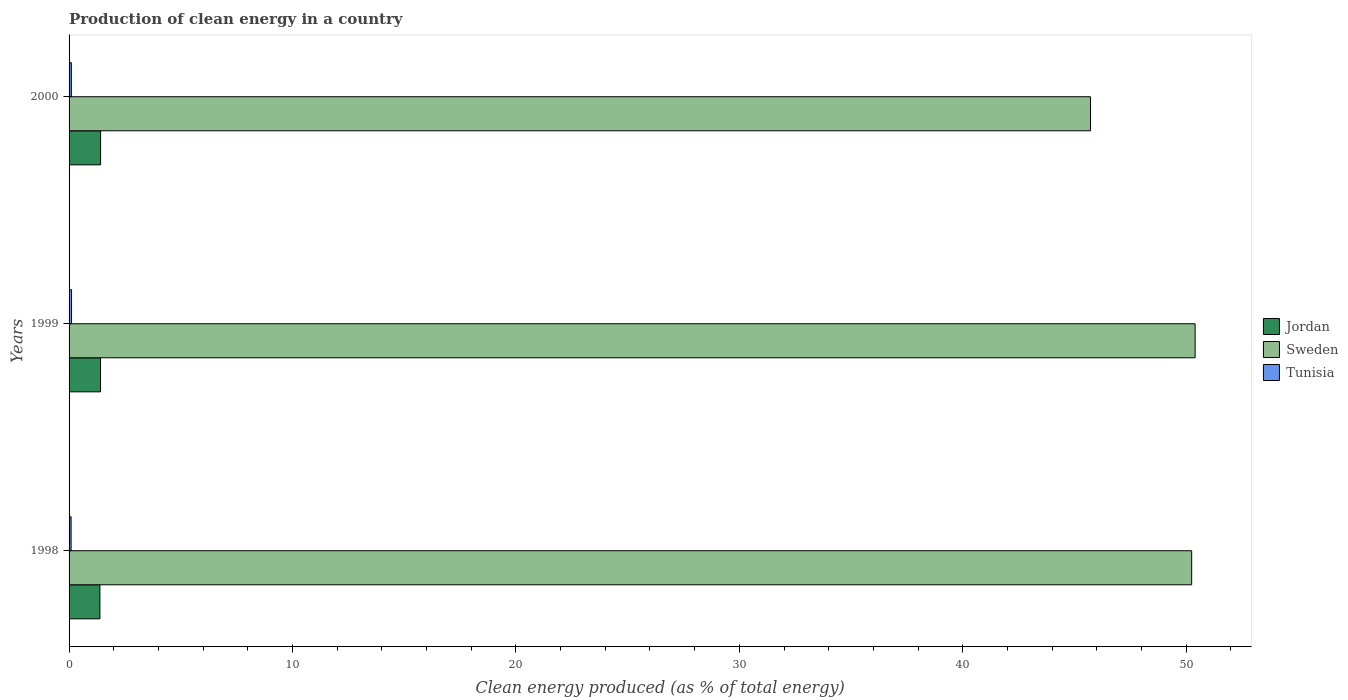How many groups of bars are there?
Your response must be concise. 3. Are the number of bars per tick equal to the number of legend labels?
Your answer should be very brief. Yes. Are the number of bars on each tick of the Y-axis equal?
Provide a short and direct response. Yes. How many bars are there on the 3rd tick from the bottom?
Offer a very short reply. 3. In how many cases, is the number of bars for a given year not equal to the number of legend labels?
Your answer should be very brief. 0. What is the percentage of clean energy produced in Sweden in 1998?
Give a very brief answer. 50.24. Across all years, what is the maximum percentage of clean energy produced in Tunisia?
Your response must be concise. 0.11. Across all years, what is the minimum percentage of clean energy produced in Sweden?
Your response must be concise. 45.71. In which year was the percentage of clean energy produced in Tunisia maximum?
Make the answer very short. 1999. What is the total percentage of clean energy produced in Jordan in the graph?
Your response must be concise. 4.2. What is the difference between the percentage of clean energy produced in Jordan in 1998 and that in 1999?
Make the answer very short. -0.03. What is the difference between the percentage of clean energy produced in Jordan in 2000 and the percentage of clean energy produced in Sweden in 1998?
Provide a succinct answer. -48.83. What is the average percentage of clean energy produced in Jordan per year?
Offer a very short reply. 1.4. In the year 1999, what is the difference between the percentage of clean energy produced in Jordan and percentage of clean energy produced in Tunisia?
Offer a terse response. 1.3. What is the ratio of the percentage of clean energy produced in Jordan in 1998 to that in 2000?
Your response must be concise. 0.98. What is the difference between the highest and the second highest percentage of clean energy produced in Sweden?
Offer a terse response. 0.15. What is the difference between the highest and the lowest percentage of clean energy produced in Tunisia?
Give a very brief answer. 0.02. What does the 2nd bar from the top in 1998 represents?
Give a very brief answer. Sweden. Is it the case that in every year, the sum of the percentage of clean energy produced in Tunisia and percentage of clean energy produced in Sweden is greater than the percentage of clean energy produced in Jordan?
Ensure brevity in your answer.  Yes. Are all the bars in the graph horizontal?
Keep it short and to the point. Yes. Does the graph contain any zero values?
Offer a terse response. No. Where does the legend appear in the graph?
Provide a short and direct response. Center right. How are the legend labels stacked?
Ensure brevity in your answer.  Vertical. What is the title of the graph?
Your response must be concise. Production of clean energy in a country. Does "Comoros" appear as one of the legend labels in the graph?
Offer a very short reply. No. What is the label or title of the X-axis?
Provide a short and direct response. Clean energy produced (as % of total energy). What is the label or title of the Y-axis?
Offer a very short reply. Years. What is the Clean energy produced (as % of total energy) in Jordan in 1998?
Your response must be concise. 1.38. What is the Clean energy produced (as % of total energy) of Sweden in 1998?
Your answer should be very brief. 50.24. What is the Clean energy produced (as % of total energy) of Tunisia in 1998?
Offer a terse response. 0.09. What is the Clean energy produced (as % of total energy) in Jordan in 1999?
Your response must be concise. 1.41. What is the Clean energy produced (as % of total energy) of Sweden in 1999?
Give a very brief answer. 50.4. What is the Clean energy produced (as % of total energy) in Tunisia in 1999?
Ensure brevity in your answer.  0.11. What is the Clean energy produced (as % of total energy) in Jordan in 2000?
Give a very brief answer. 1.41. What is the Clean energy produced (as % of total energy) in Sweden in 2000?
Your answer should be very brief. 45.71. What is the Clean energy produced (as % of total energy) of Tunisia in 2000?
Make the answer very short. 0.1. Across all years, what is the maximum Clean energy produced (as % of total energy) of Jordan?
Give a very brief answer. 1.41. Across all years, what is the maximum Clean energy produced (as % of total energy) in Sweden?
Your answer should be compact. 50.4. Across all years, what is the maximum Clean energy produced (as % of total energy) of Tunisia?
Make the answer very short. 0.11. Across all years, what is the minimum Clean energy produced (as % of total energy) in Jordan?
Your answer should be compact. 1.38. Across all years, what is the minimum Clean energy produced (as % of total energy) in Sweden?
Your answer should be very brief. 45.71. Across all years, what is the minimum Clean energy produced (as % of total energy) in Tunisia?
Provide a succinct answer. 0.09. What is the total Clean energy produced (as % of total energy) of Jordan in the graph?
Keep it short and to the point. 4.2. What is the total Clean energy produced (as % of total energy) in Sweden in the graph?
Provide a short and direct response. 146.36. What is the total Clean energy produced (as % of total energy) of Tunisia in the graph?
Give a very brief answer. 0.3. What is the difference between the Clean energy produced (as % of total energy) of Jordan in 1998 and that in 1999?
Your answer should be very brief. -0.03. What is the difference between the Clean energy produced (as % of total energy) of Sweden in 1998 and that in 1999?
Provide a short and direct response. -0.15. What is the difference between the Clean energy produced (as % of total energy) in Tunisia in 1998 and that in 1999?
Your response must be concise. -0.02. What is the difference between the Clean energy produced (as % of total energy) in Jordan in 1998 and that in 2000?
Offer a very short reply. -0.03. What is the difference between the Clean energy produced (as % of total energy) of Sweden in 1998 and that in 2000?
Provide a short and direct response. 4.53. What is the difference between the Clean energy produced (as % of total energy) in Tunisia in 1998 and that in 2000?
Your answer should be compact. -0.01. What is the difference between the Clean energy produced (as % of total energy) of Jordan in 1999 and that in 2000?
Your response must be concise. -0. What is the difference between the Clean energy produced (as % of total energy) in Sweden in 1999 and that in 2000?
Keep it short and to the point. 4.68. What is the difference between the Clean energy produced (as % of total energy) in Tunisia in 1999 and that in 2000?
Your response must be concise. 0.01. What is the difference between the Clean energy produced (as % of total energy) in Jordan in 1998 and the Clean energy produced (as % of total energy) in Sweden in 1999?
Offer a very short reply. -49.02. What is the difference between the Clean energy produced (as % of total energy) of Jordan in 1998 and the Clean energy produced (as % of total energy) of Tunisia in 1999?
Offer a very short reply. 1.27. What is the difference between the Clean energy produced (as % of total energy) of Sweden in 1998 and the Clean energy produced (as % of total energy) of Tunisia in 1999?
Keep it short and to the point. 50.13. What is the difference between the Clean energy produced (as % of total energy) of Jordan in 1998 and the Clean energy produced (as % of total energy) of Sweden in 2000?
Provide a short and direct response. -44.33. What is the difference between the Clean energy produced (as % of total energy) in Jordan in 1998 and the Clean energy produced (as % of total energy) in Tunisia in 2000?
Your answer should be compact. 1.28. What is the difference between the Clean energy produced (as % of total energy) in Sweden in 1998 and the Clean energy produced (as % of total energy) in Tunisia in 2000?
Provide a short and direct response. 50.14. What is the difference between the Clean energy produced (as % of total energy) of Jordan in 1999 and the Clean energy produced (as % of total energy) of Sweden in 2000?
Offer a very short reply. -44.31. What is the difference between the Clean energy produced (as % of total energy) of Jordan in 1999 and the Clean energy produced (as % of total energy) of Tunisia in 2000?
Provide a succinct answer. 1.31. What is the difference between the Clean energy produced (as % of total energy) in Sweden in 1999 and the Clean energy produced (as % of total energy) in Tunisia in 2000?
Your response must be concise. 50.3. What is the average Clean energy produced (as % of total energy) of Jordan per year?
Keep it short and to the point. 1.4. What is the average Clean energy produced (as % of total energy) in Sweden per year?
Provide a succinct answer. 48.79. What is the average Clean energy produced (as % of total energy) of Tunisia per year?
Your response must be concise. 0.1. In the year 1998, what is the difference between the Clean energy produced (as % of total energy) in Jordan and Clean energy produced (as % of total energy) in Sweden?
Offer a very short reply. -48.86. In the year 1998, what is the difference between the Clean energy produced (as % of total energy) in Jordan and Clean energy produced (as % of total energy) in Tunisia?
Your response must be concise. 1.29. In the year 1998, what is the difference between the Clean energy produced (as % of total energy) in Sweden and Clean energy produced (as % of total energy) in Tunisia?
Keep it short and to the point. 50.15. In the year 1999, what is the difference between the Clean energy produced (as % of total energy) of Jordan and Clean energy produced (as % of total energy) of Sweden?
Your answer should be compact. -48.99. In the year 1999, what is the difference between the Clean energy produced (as % of total energy) of Jordan and Clean energy produced (as % of total energy) of Tunisia?
Make the answer very short. 1.3. In the year 1999, what is the difference between the Clean energy produced (as % of total energy) of Sweden and Clean energy produced (as % of total energy) of Tunisia?
Give a very brief answer. 50.29. In the year 2000, what is the difference between the Clean energy produced (as % of total energy) in Jordan and Clean energy produced (as % of total energy) in Sweden?
Ensure brevity in your answer.  -44.3. In the year 2000, what is the difference between the Clean energy produced (as % of total energy) in Jordan and Clean energy produced (as % of total energy) in Tunisia?
Your response must be concise. 1.31. In the year 2000, what is the difference between the Clean energy produced (as % of total energy) in Sweden and Clean energy produced (as % of total energy) in Tunisia?
Give a very brief answer. 45.61. What is the ratio of the Clean energy produced (as % of total energy) of Jordan in 1998 to that in 1999?
Provide a short and direct response. 0.98. What is the ratio of the Clean energy produced (as % of total energy) in Sweden in 1998 to that in 1999?
Ensure brevity in your answer.  1. What is the ratio of the Clean energy produced (as % of total energy) in Tunisia in 1998 to that in 1999?
Ensure brevity in your answer.  0.83. What is the ratio of the Clean energy produced (as % of total energy) in Jordan in 1998 to that in 2000?
Your answer should be compact. 0.98. What is the ratio of the Clean energy produced (as % of total energy) of Sweden in 1998 to that in 2000?
Offer a very short reply. 1.1. What is the ratio of the Clean energy produced (as % of total energy) of Tunisia in 1998 to that in 2000?
Your answer should be very brief. 0.89. What is the ratio of the Clean energy produced (as % of total energy) in Sweden in 1999 to that in 2000?
Offer a terse response. 1.1. What is the ratio of the Clean energy produced (as % of total energy) of Tunisia in 1999 to that in 2000?
Give a very brief answer. 1.07. What is the difference between the highest and the second highest Clean energy produced (as % of total energy) in Jordan?
Offer a very short reply. 0. What is the difference between the highest and the second highest Clean energy produced (as % of total energy) of Sweden?
Your answer should be very brief. 0.15. What is the difference between the highest and the second highest Clean energy produced (as % of total energy) in Tunisia?
Ensure brevity in your answer.  0.01. What is the difference between the highest and the lowest Clean energy produced (as % of total energy) in Jordan?
Offer a terse response. 0.03. What is the difference between the highest and the lowest Clean energy produced (as % of total energy) in Sweden?
Your response must be concise. 4.68. What is the difference between the highest and the lowest Clean energy produced (as % of total energy) of Tunisia?
Provide a succinct answer. 0.02. 